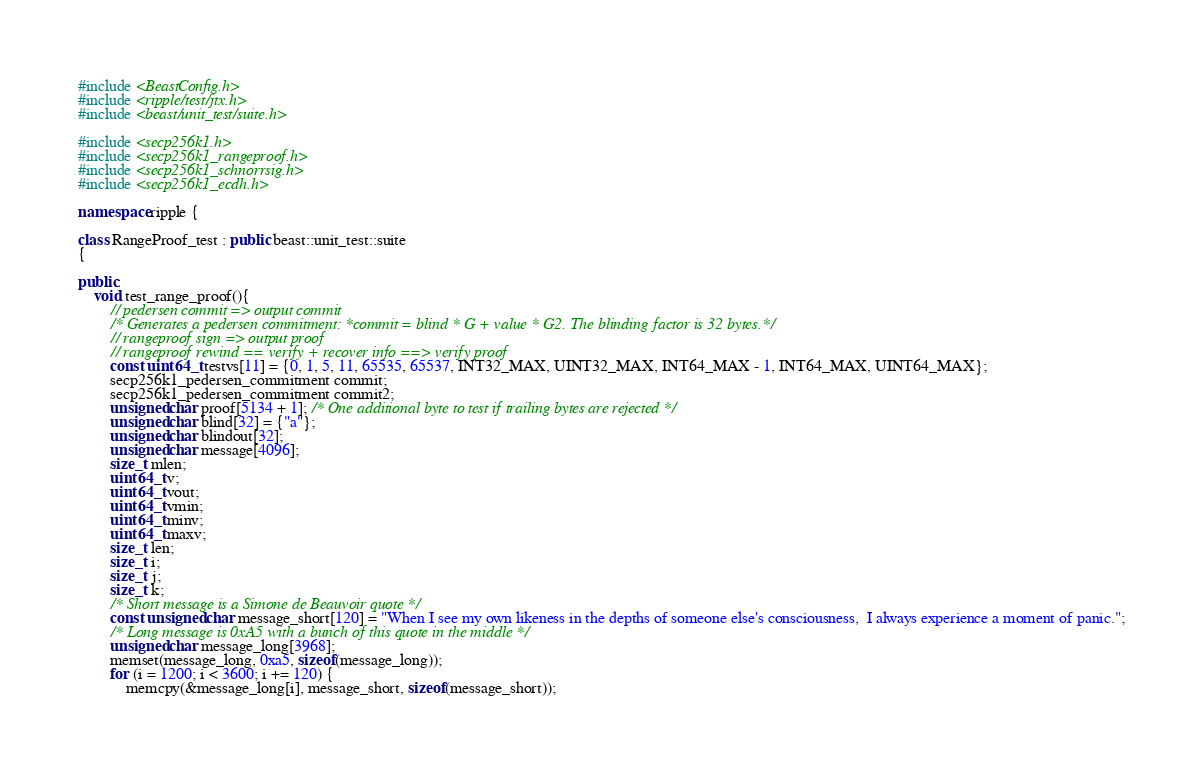<code> <loc_0><loc_0><loc_500><loc_500><_C++_>
#include <BeastConfig.h>
#include <ripple/test/jtx.h>
#include <beast/unit_test/suite.h>

#include <secp256k1.h>
#include <secp256k1_rangeproof.h>
#include <secp256k1_schnorrsig.h>
#include <secp256k1_ecdh.h>

namespace ripple {

class RangeProof_test : public beast::unit_test::suite
{

public:
    void test_range_proof(){
        // pedersen commit => output commit
        /* Generates a pedersen commitment: *commit = blind * G + value * G2. The blinding factor is 32 bytes.*/
        // rangeproof sign => output proof
        // rangeproof rewind == verify + recover info ==> verify proof
        const uint64_t testvs[11] = {0, 1, 5, 11, 65535, 65537, INT32_MAX, UINT32_MAX, INT64_MAX - 1, INT64_MAX, UINT64_MAX};
        secp256k1_pedersen_commitment commit;
        secp256k1_pedersen_commitment commit2;
        unsigned char proof[5134 + 1]; /* One additional byte to test if trailing bytes are rejected */
        unsigned char blind[32] = {"a"};
        unsigned char blindout[32];
        unsigned char message[4096];
        size_t mlen;
        uint64_t v;
        uint64_t vout;
        uint64_t vmin;
        uint64_t minv;
        uint64_t maxv;
        size_t len;
        size_t i;
        size_t j;
        size_t k;
        /* Short message is a Simone de Beauvoir quote */
        const unsigned char message_short[120] = "When I see my own likeness in the depths of someone else's consciousness,  I always experience a moment of panic.";
        /* Long message is 0xA5 with a bunch of this quote in the middle */
        unsigned char message_long[3968];
        memset(message_long, 0xa5, sizeof(message_long));
        for (i = 1200; i < 3600; i += 120) {
            memcpy(&message_long[i], message_short, sizeof(message_short));</code> 